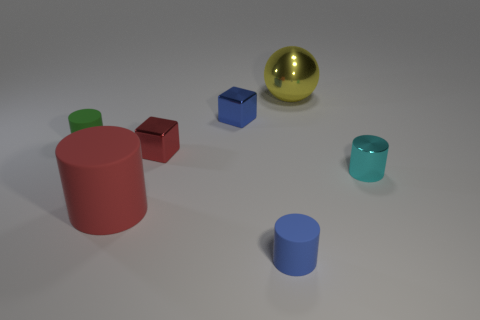Does the tiny green rubber object to the left of the yellow shiny ball have the same shape as the big red thing?
Ensure brevity in your answer.  Yes. What is the material of the tiny object that is the same color as the big cylinder?
Offer a very short reply. Metal. What number of metallic blocks have the same color as the large ball?
Your response must be concise. 0. What shape is the small metal thing in front of the small red object left of the blue metallic block?
Make the answer very short. Cylinder. Are there any small shiny objects of the same shape as the large matte object?
Keep it short and to the point. Yes. Do the big matte cylinder and the small metallic block in front of the small green rubber cylinder have the same color?
Your answer should be very brief. Yes. What is the size of the object that is the same color as the large rubber cylinder?
Ensure brevity in your answer.  Small. Is there another green matte cylinder that has the same size as the green rubber cylinder?
Provide a short and direct response. No. Are the cyan thing and the blue thing behind the metallic cylinder made of the same material?
Give a very brief answer. Yes. Are there more blue metal cubes than gray cylinders?
Your answer should be compact. Yes. 